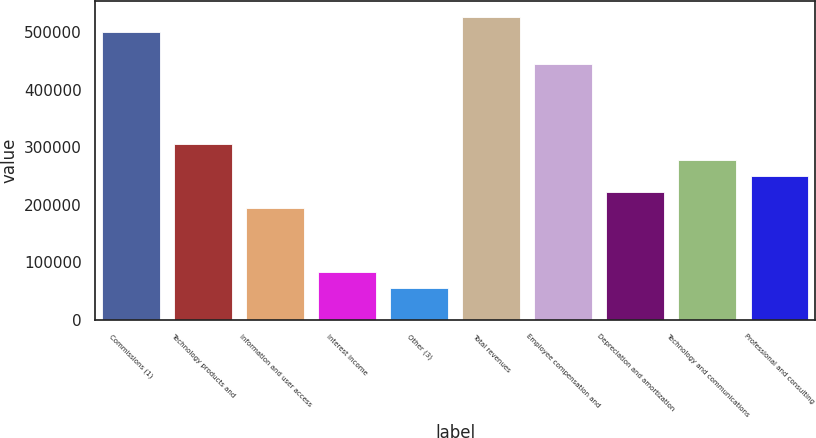Convert chart. <chart><loc_0><loc_0><loc_500><loc_500><bar_chart><fcel>Commissions (1)<fcel>Technology products and<fcel>Information and user access<fcel>Interest income<fcel>Other (3)<fcel>Total revenues<fcel>Employee compensation and<fcel>Depreciation and amortization<fcel>Technology and communications<fcel>Professional and consulting<nl><fcel>499114<fcel>305015<fcel>194100<fcel>83186.1<fcel>55457.5<fcel>526843<fcel>443657<fcel>221829<fcel>277286<fcel>249557<nl></chart> 